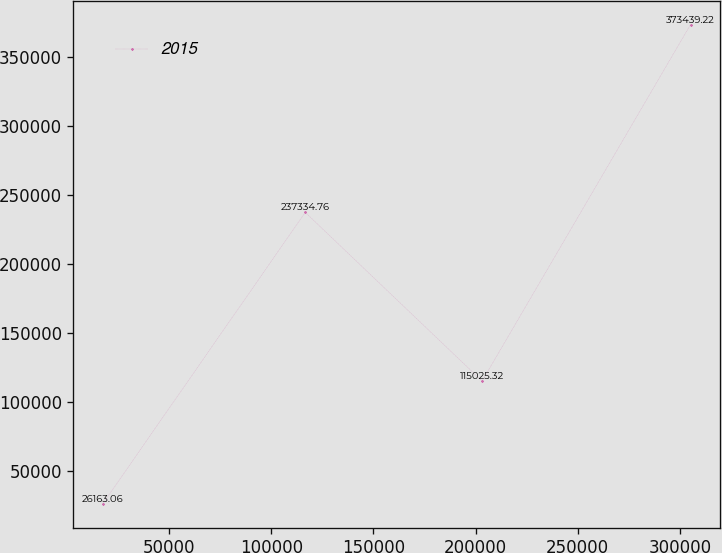Convert chart to OTSL. <chart><loc_0><loc_0><loc_500><loc_500><line_chart><ecel><fcel>2015<nl><fcel>17529.8<fcel>26163.1<nl><fcel>116635<fcel>237335<nl><fcel>203203<fcel>115025<nl><fcel>305240<fcel>373439<nl></chart> 